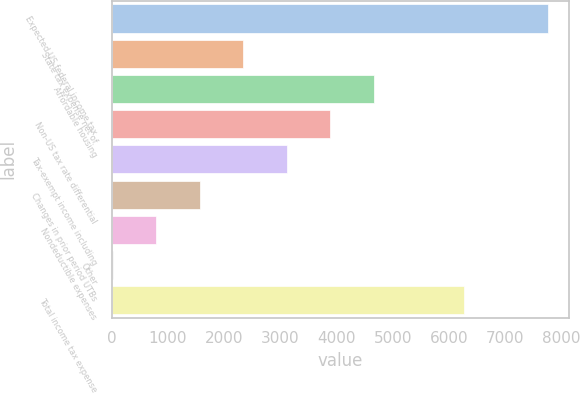Convert chart. <chart><loc_0><loc_0><loc_500><loc_500><bar_chart><fcel>Expected US federal income tax<fcel>State tax expense net of<fcel>Affordable housing<fcel>Non-US tax rate differential<fcel>Tax-exempt income including<fcel>Changes in prior period UTBs<fcel>Nondeductible expenses<fcel>Other<fcel>Total income tax expense<nl><fcel>7754<fcel>2340.9<fcel>4660.8<fcel>3887.5<fcel>3114.2<fcel>1567.6<fcel>794.3<fcel>21<fcel>6266<nl></chart> 